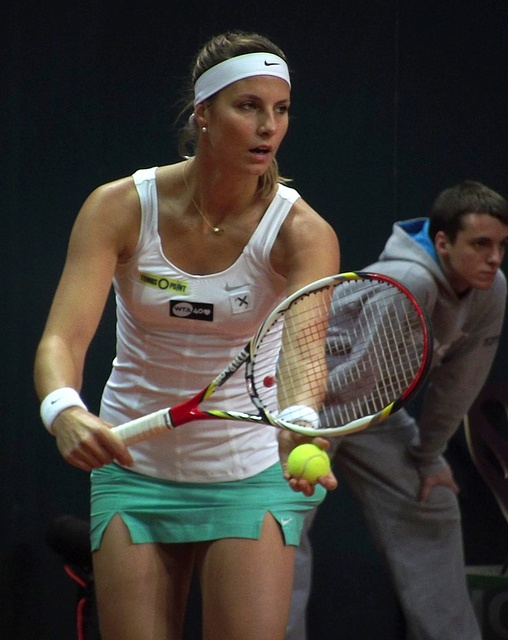Describe the objects in this image and their specific colors. I can see people in black, gray, maroon, and darkgray tones, people in black, gray, maroon, and darkgray tones, tennis racket in black, gray, darkgray, and tan tones, and sports ball in black, yellow, lightgreen, olive, and khaki tones in this image. 